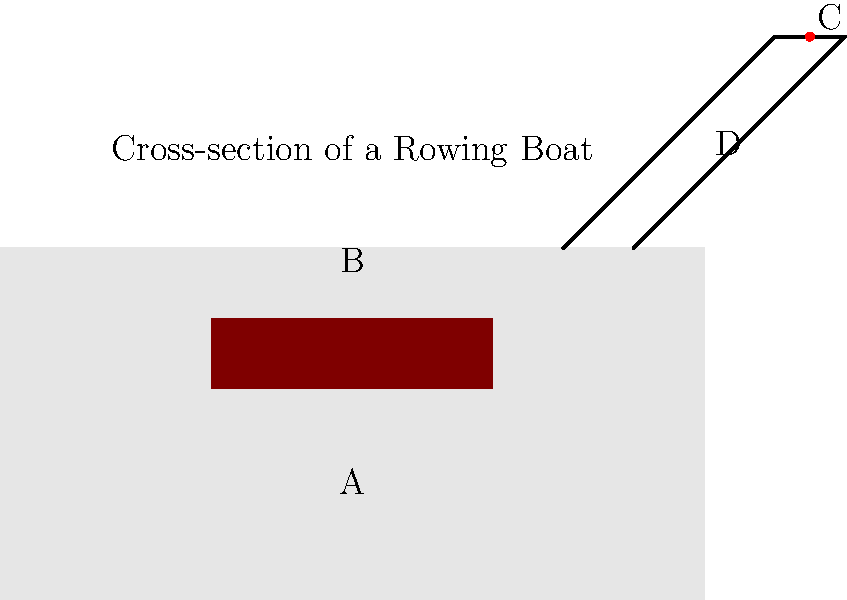In the cross-section diagram of a rowing boat above, identify the parts labeled A, B, C, and D. Which of these parts is responsible for holding the oar in place during rowing? To answer this question, let's analyze each labeled part of the rowing boat:

1. Part A: This is the seat where the rower sits. It's positioned low in the boat to maintain stability.

2. Part B: This represents the hull or shell of the boat. It's the main body that provides buoyancy and determines the boat's shape in the water.

3. Part C: This small circular part at the top of the rigger is the oarlock. It's a pivoting device that holds the oar in place and allows it to rotate during the rowing motion.

4. Part D: This is the rigger, an outrigger structure that extends from the side of the boat. It supports the oarlock and helps transfer the rower's power to the water.

Among these parts, the one responsible for holding the oar in place during rowing is the oarlock (Part C). The oarlock is crucial as it:
- Provides a pivot point for the oar
- Keeps the oar at a consistent height above the water
- Allows the oar to rotate freely during the rowing stroke
- Transfers the rower's power from the oar to the boat

Therefore, the correct answer is Part C, the oarlock.
Answer: C (oarlock) 